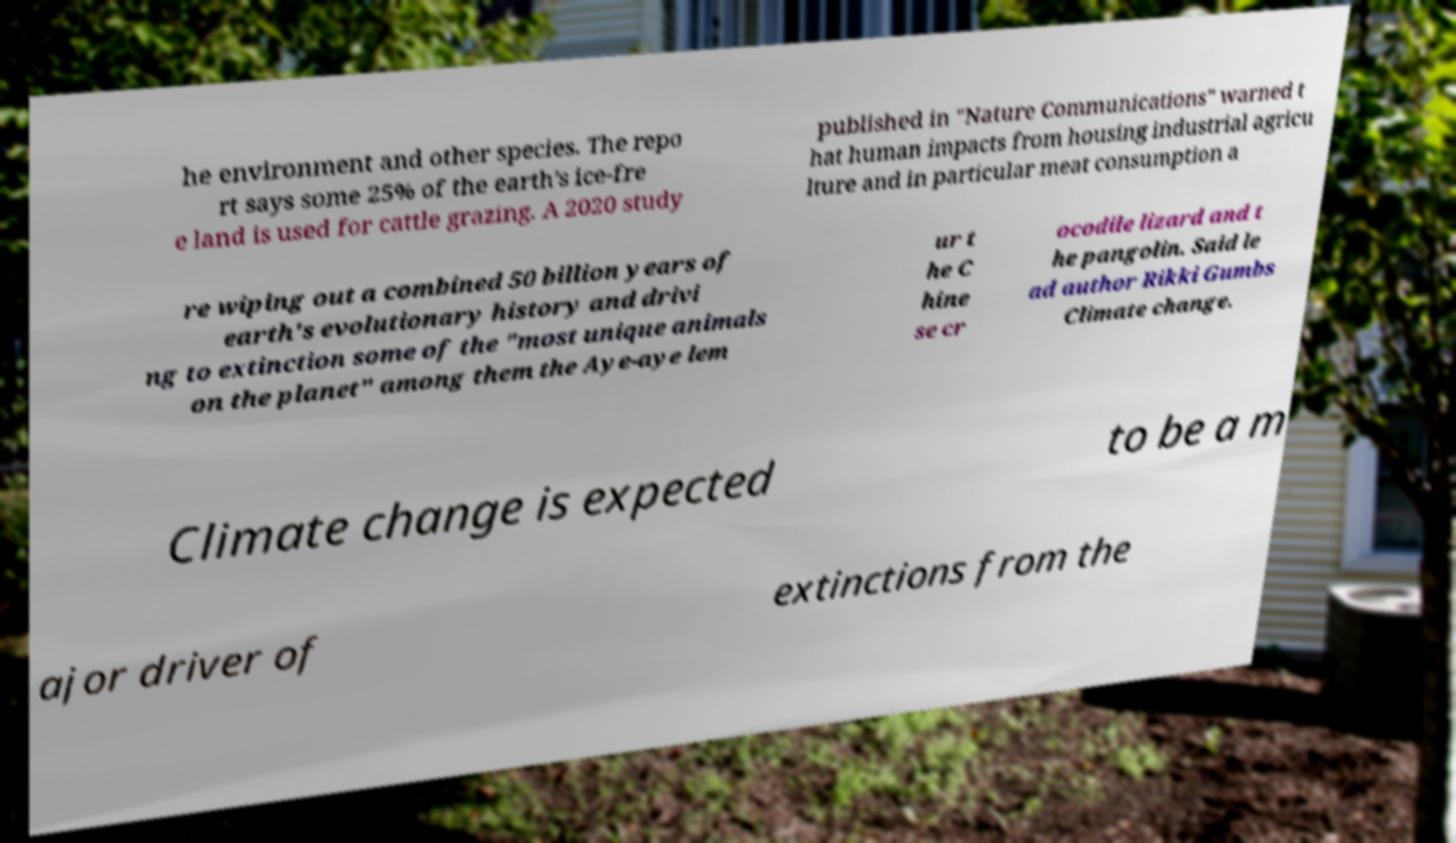Please identify and transcribe the text found in this image. he environment and other species. The repo rt says some 25% of the earth's ice-fre e land is used for cattle grazing. A 2020 study published in "Nature Communications" warned t hat human impacts from housing industrial agricu lture and in particular meat consumption a re wiping out a combined 50 billion years of earth's evolutionary history and drivi ng to extinction some of the "most unique animals on the planet" among them the Aye-aye lem ur t he C hine se cr ocodile lizard and t he pangolin. Said le ad author Rikki Gumbs Climate change. Climate change is expected to be a m ajor driver of extinctions from the 